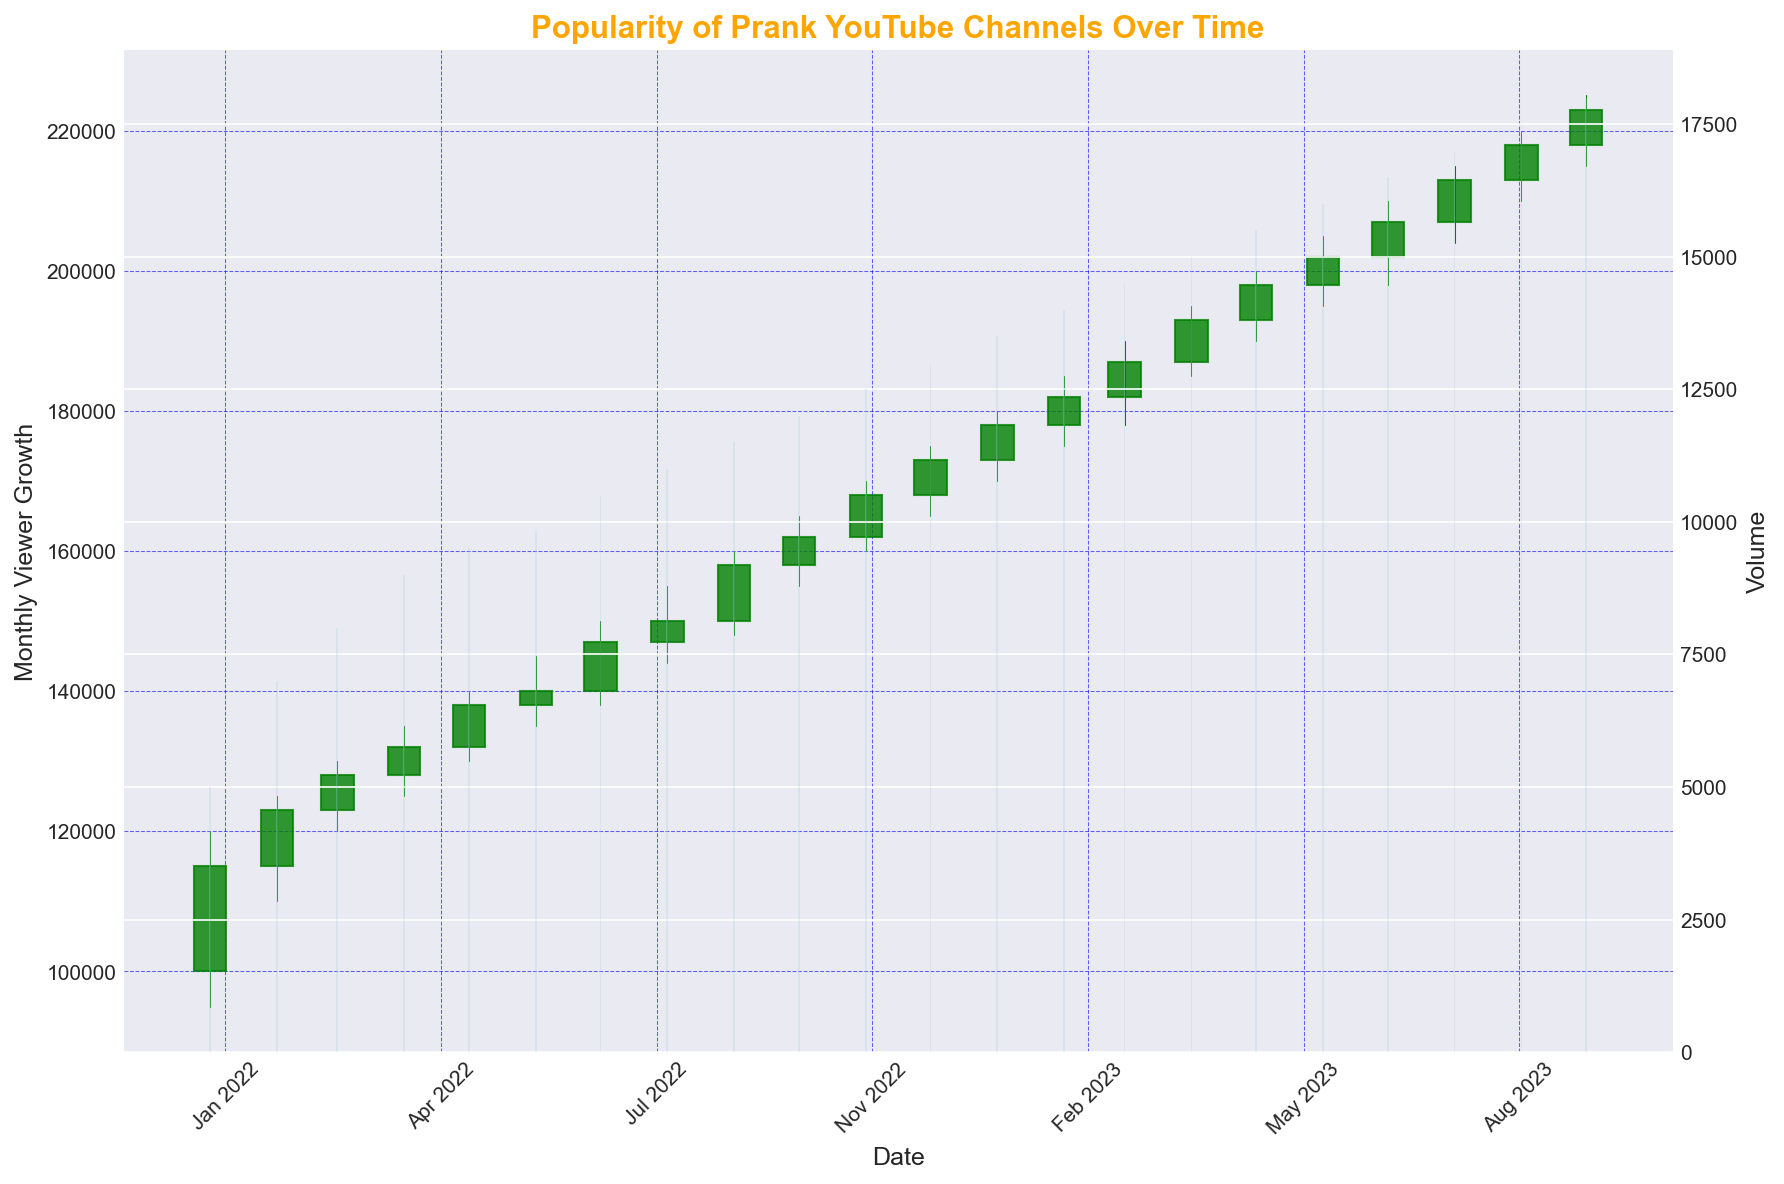What's the highest monthly viewer count reached by any prank YouTube channel in 2023 so far? Look at the "High" values for each month in 2023. The highest viewer count is in October 2023 with 225,000.
Answer: 225,000 Which month had the highest volume of viewers in 2022? Compare the "Volume" values for each month in 2022. December 2022 has the highest volume with 13,000.
Answer: December 2022 How many months in 2023 had a closing monthly viewer count higher than the closing viewer count in January 2023? The closing viewer count in January 2023 was 178,000. Check each month in 2023: February to October are all higher. There are 9 months.
Answer: 9 Which month experienced the greatest increase in closing viewers compared to the previous month in 2022? Calculate the difference in the "Close" values for each month from the previous month in 2022. The greatest increase is from January to February (123,000 - 115,000 = 8,000).
Answer: February 2022 What's the average monthly viewer count increase from January 2022 to October 2023? Calculate the differences for each month: (123,000-115,000) + (128,000-123,000) + (132,000-128,000) + ... + (223,000-218,000), and then divide by the number of differences. This gives (8,000 + 5,000 + 4,000 + ... + 5,000)/21.
Answer: 4,532 Compared to December 2022, how many months before did the closing viewer count exceed 160,000? December 2022 closes at 173,000. Check months before it exceeding 160,000 are October and November.
Answer: 2 In which month did the prank YouTube channels have the lowest monthly viewer growth in 2023? Refer to the "Close" values in 2023 to find the month with smallest growth, March has the smallest jump (187,000 - 182,000 gives 5,000).
Answer: March 2023 What is the average volume of viewers per month in the year 2022? Sum up the "Volume" values from January to December in 2022 and divide by 12. (5000 + 7000 + 8000 + 9000 + 9500 + 9800 + 10500 + 11000 + 11500 + 12000 + 12500 + 13000) / 12.
Answer: 9,250 How many times in total did the prank YouTube channels' monthly viewer count close higher than it opened within 2023? Observe the "Open" and "Close" values for months in 2023 and count the occurrences when "Close" > "Open". All months from January to October 2023 meet this criterion.
Answer: 10 